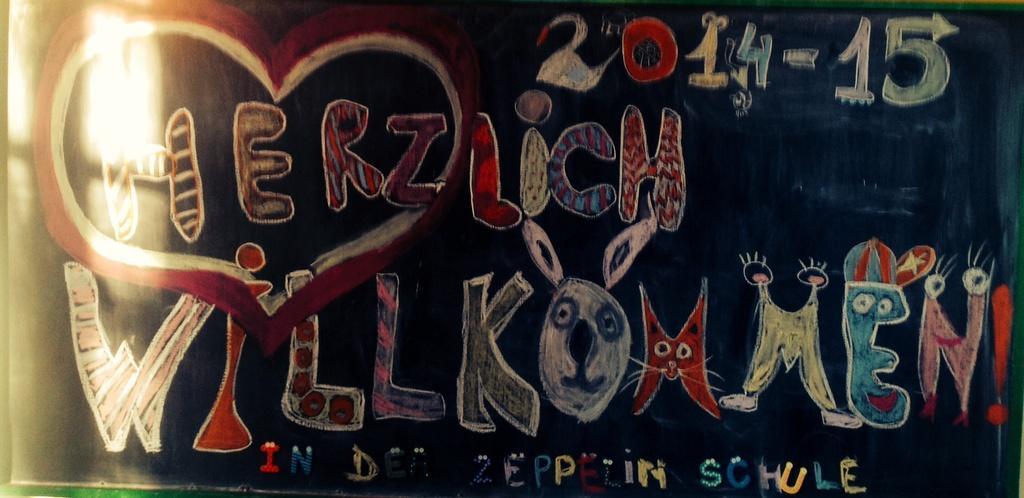Describe this image in one or two sentences. This image consists of a black board on which something is written along with the date. 